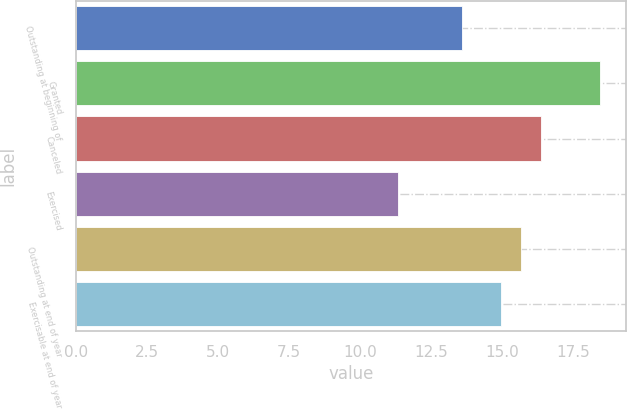Convert chart. <chart><loc_0><loc_0><loc_500><loc_500><bar_chart><fcel>Outstanding at beginning of<fcel>Granted<fcel>Canceled<fcel>Exercised<fcel>Outstanding at end of year<fcel>Exercisable at end of year<nl><fcel>13.58<fcel>18.42<fcel>16.36<fcel>11.31<fcel>15.65<fcel>14.94<nl></chart> 